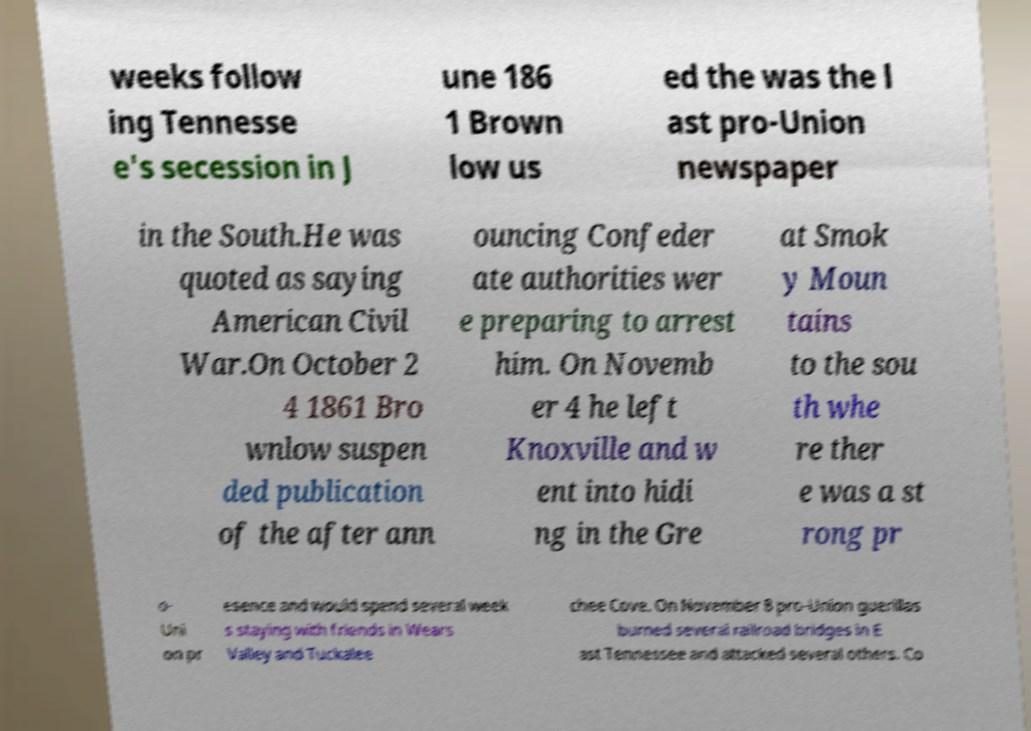I need the written content from this picture converted into text. Can you do that? weeks follow ing Tennesse e's secession in J une 186 1 Brown low us ed the was the l ast pro-Union newspaper in the South.He was quoted as saying American Civil War.On October 2 4 1861 Bro wnlow suspen ded publication of the after ann ouncing Confeder ate authorities wer e preparing to arrest him. On Novemb er 4 he left Knoxville and w ent into hidi ng in the Gre at Smok y Moun tains to the sou th whe re ther e was a st rong pr o- Uni on pr esence and would spend several week s staying with friends in Wears Valley and Tuckalee chee Cove. On November 8 pro-Union guerillas burned several railroad bridges in E ast Tennessee and attacked several others. Co 